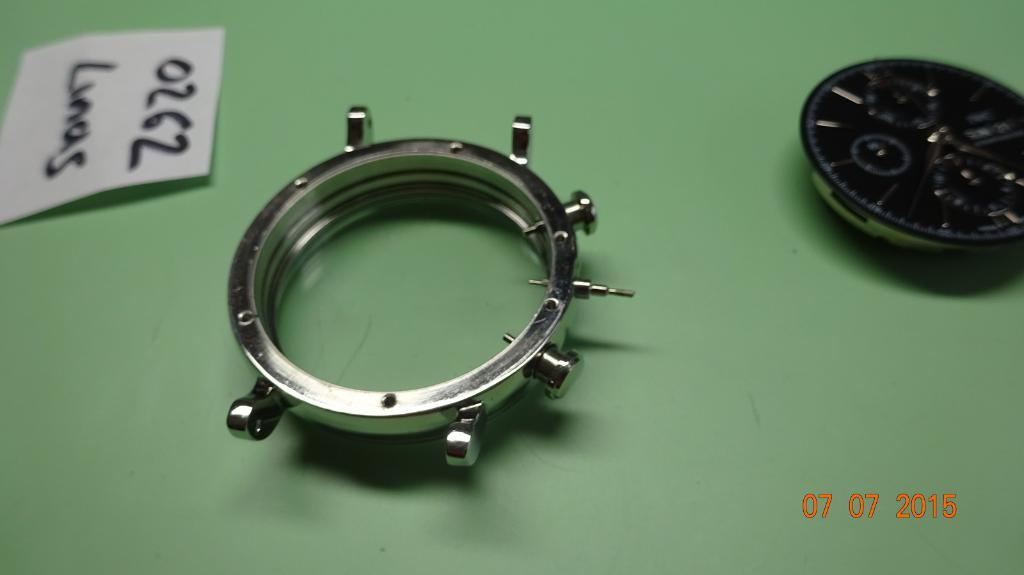Provide a one-sentence caption for the provided image. Some parts for the construction of a watch were photographed on 07/07/2015. 